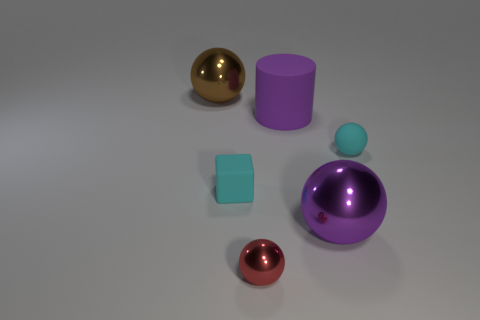Are there an equal number of large things behind the tiny matte cube and objects that are to the right of the brown metallic ball?
Ensure brevity in your answer.  No. What number of tiny cyan objects have the same material as the cylinder?
Give a very brief answer. 2. The other thing that is the same color as the big rubber thing is what shape?
Provide a short and direct response. Sphere. There is a cyan thing on the left side of the big ball that is on the right side of the brown object; what is its size?
Offer a very short reply. Small. Do the small matte thing that is on the right side of the big purple metallic thing and the rubber thing that is on the left side of the small shiny thing have the same shape?
Make the answer very short. No. Is the number of large purple metallic spheres left of the big purple matte cylinder the same as the number of large brown metallic objects?
Give a very brief answer. No. There is a tiny rubber object that is the same shape as the purple metal object; what is its color?
Your answer should be very brief. Cyan. Do the big sphere that is in front of the purple rubber cylinder and the large brown sphere have the same material?
Ensure brevity in your answer.  Yes. How many tiny objects are purple metal spheres or rubber objects?
Offer a terse response. 2. The brown thing is what size?
Provide a short and direct response. Large. 